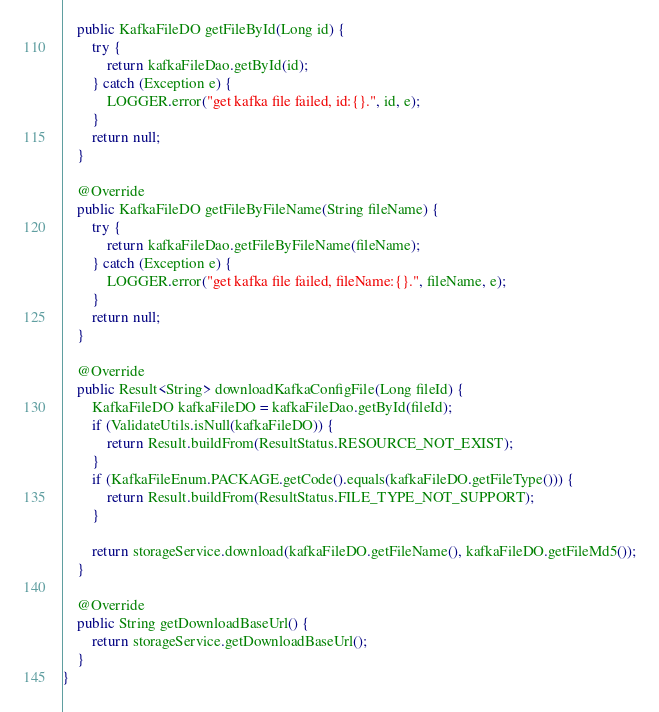<code> <loc_0><loc_0><loc_500><loc_500><_Java_>    public KafkaFileDO getFileById(Long id) {
        try {
            return kafkaFileDao.getById(id);
        } catch (Exception e) {
            LOGGER.error("get kafka file failed, id:{}.", id, e);
        }
        return null;
    }

    @Override
    public KafkaFileDO getFileByFileName(String fileName) {
        try {
            return kafkaFileDao.getFileByFileName(fileName);
        } catch (Exception e) {
            LOGGER.error("get kafka file failed, fileName:{}.", fileName, e);
        }
        return null;
    }

    @Override
    public Result<String> downloadKafkaConfigFile(Long fileId) {
        KafkaFileDO kafkaFileDO = kafkaFileDao.getById(fileId);
        if (ValidateUtils.isNull(kafkaFileDO)) {
            return Result.buildFrom(ResultStatus.RESOURCE_NOT_EXIST);
        }
        if (KafkaFileEnum.PACKAGE.getCode().equals(kafkaFileDO.getFileType())) {
            return Result.buildFrom(ResultStatus.FILE_TYPE_NOT_SUPPORT);
        }

        return storageService.download(kafkaFileDO.getFileName(), kafkaFileDO.getFileMd5());
    }

    @Override
    public String getDownloadBaseUrl() {
        return storageService.getDownloadBaseUrl();
    }
}
</code> 